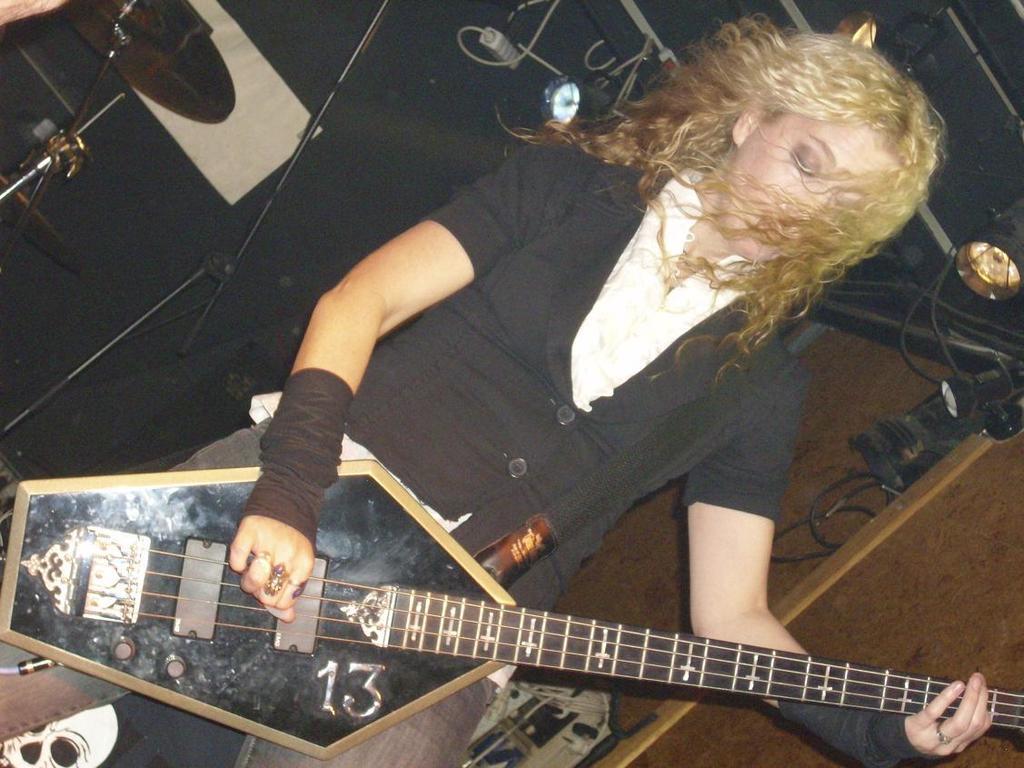Could you give a brief overview of what you see in this image? In this picture there is a person standing and playing guitar. At the back there is a drum and microphone and there are objects. At the top there are lights and there are wires. At the bottom left there is a picture of a skull. 